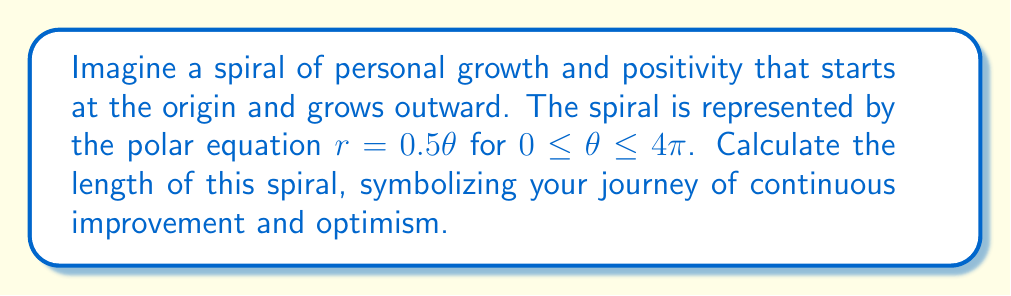Teach me how to tackle this problem. To find the length of the spiral, we'll use the arc length formula for polar curves:

$$L = \int_a^b \sqrt{r^2 + \left(\frac{dr}{d\theta}\right)^2} d\theta$$

For our spiral:
1) $r = 0.5\theta$
2) $\frac{dr}{d\theta} = 0.5$

Substituting these into the formula:

$$L = \int_0^{4\pi} \sqrt{(0.5\theta)^2 + (0.5)^2} d\theta$$

$$= \int_0^{4\pi} \sqrt{0.25\theta^2 + 0.25} d\theta$$

$$= \frac{1}{2} \int_0^{4\pi} \sqrt{\theta^2 + 1} d\theta$$

This integral can be solved using the substitution $\theta = \sinh u$:

$$L = \frac{1}{2} \int_0^{\sinh^{-1}(4\pi)} \sqrt{\sinh^2 u + 1} \cosh u du$$

$$= \frac{1}{2} \int_0^{\sinh^{-1}(4\pi)} \cosh^2 u du$$

Using the identity $\cosh^2 u = \frac{1}{2}(\cosh 2u + 1)$:

$$L = \frac{1}{4} \int_0^{\sinh^{-1}(4\pi)} (\cosh 2u + 1) du$$

$$= \frac{1}{4} \left[\frac{1}{2}\sinh 2u + u\right]_0^{\sinh^{-1}(4\pi)}$$

$$= \frac{1}{8}\sinh(2\sinh^{-1}(4\pi)) + \frac{1}{4}\sinh^{-1}(4\pi)$$

Using the identity $\sinh(2\sinh^{-1}x) = 2x\sqrt{1+x^2}$:

$$L = \frac{1}{4}(4\pi)\sqrt{1+(4\pi)^2} + \frac{1}{4}\sinh^{-1}(4\pi)$$

$$= \pi\sqrt{1+16\pi^2} + \frac{1}{4}\sinh^{-1}(4\pi)$$

This is the exact length of the spiral. For a numerical approximation:

$$L \approx 39.9486$$
Answer: The length of the spiral is $\pi\sqrt{1+16\pi^2} + \frac{1}{4}\sinh^{-1}(4\pi)$, or approximately 39.9486 units. 